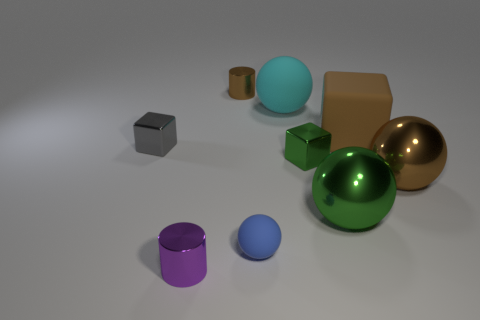Subtract all brown metal balls. How many balls are left? 3 Add 1 gray metallic cylinders. How many objects exist? 10 Subtract all gray cubes. How many cubes are left? 2 Subtract 2 balls. How many balls are left? 2 Subtract 1 brown cubes. How many objects are left? 8 Subtract all balls. How many objects are left? 5 Subtract all cyan cubes. Subtract all gray cylinders. How many cubes are left? 3 Subtract all cyan cubes. How many purple cylinders are left? 1 Subtract all brown matte objects. Subtract all metal objects. How many objects are left? 2 Add 1 brown rubber things. How many brown rubber things are left? 2 